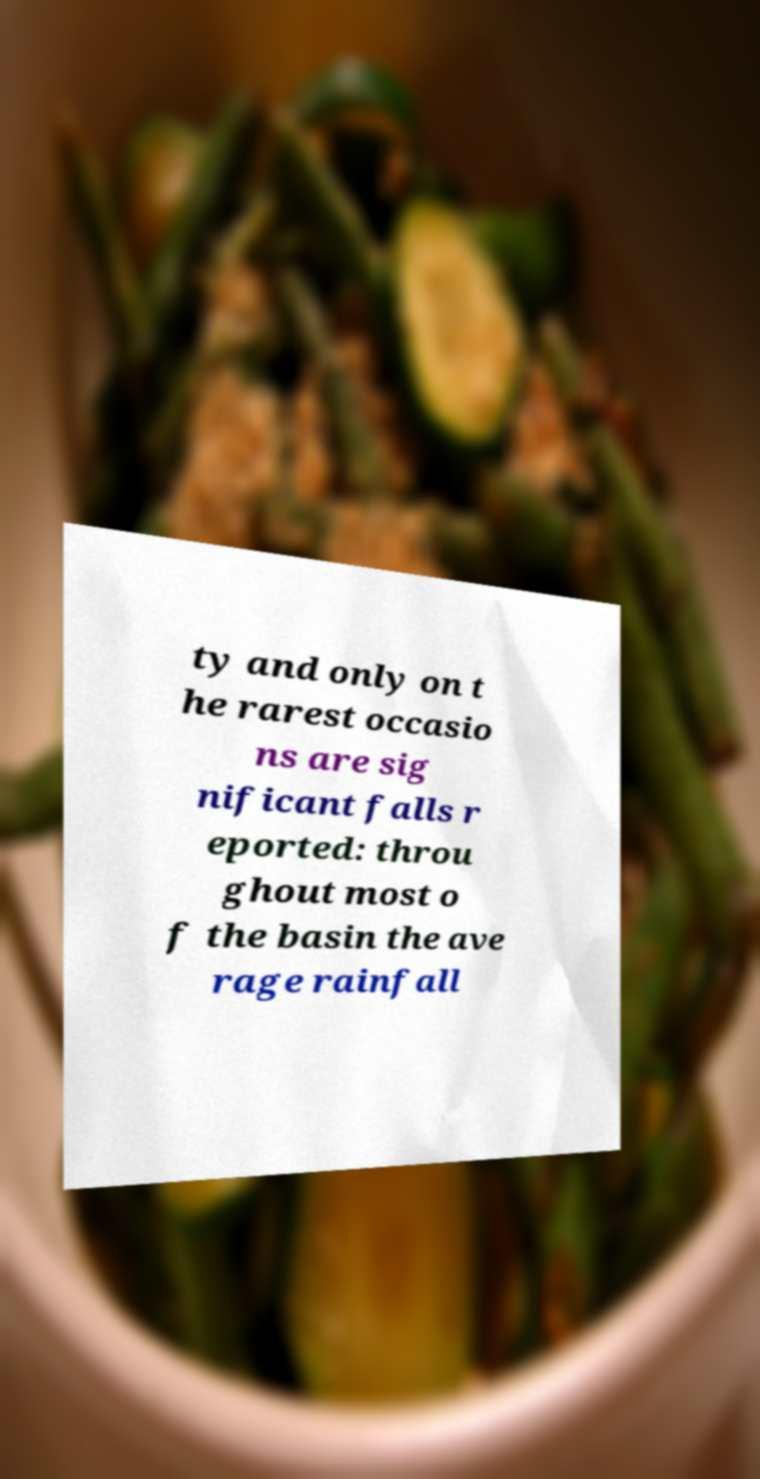Please identify and transcribe the text found in this image. ty and only on t he rarest occasio ns are sig nificant falls r eported: throu ghout most o f the basin the ave rage rainfall 